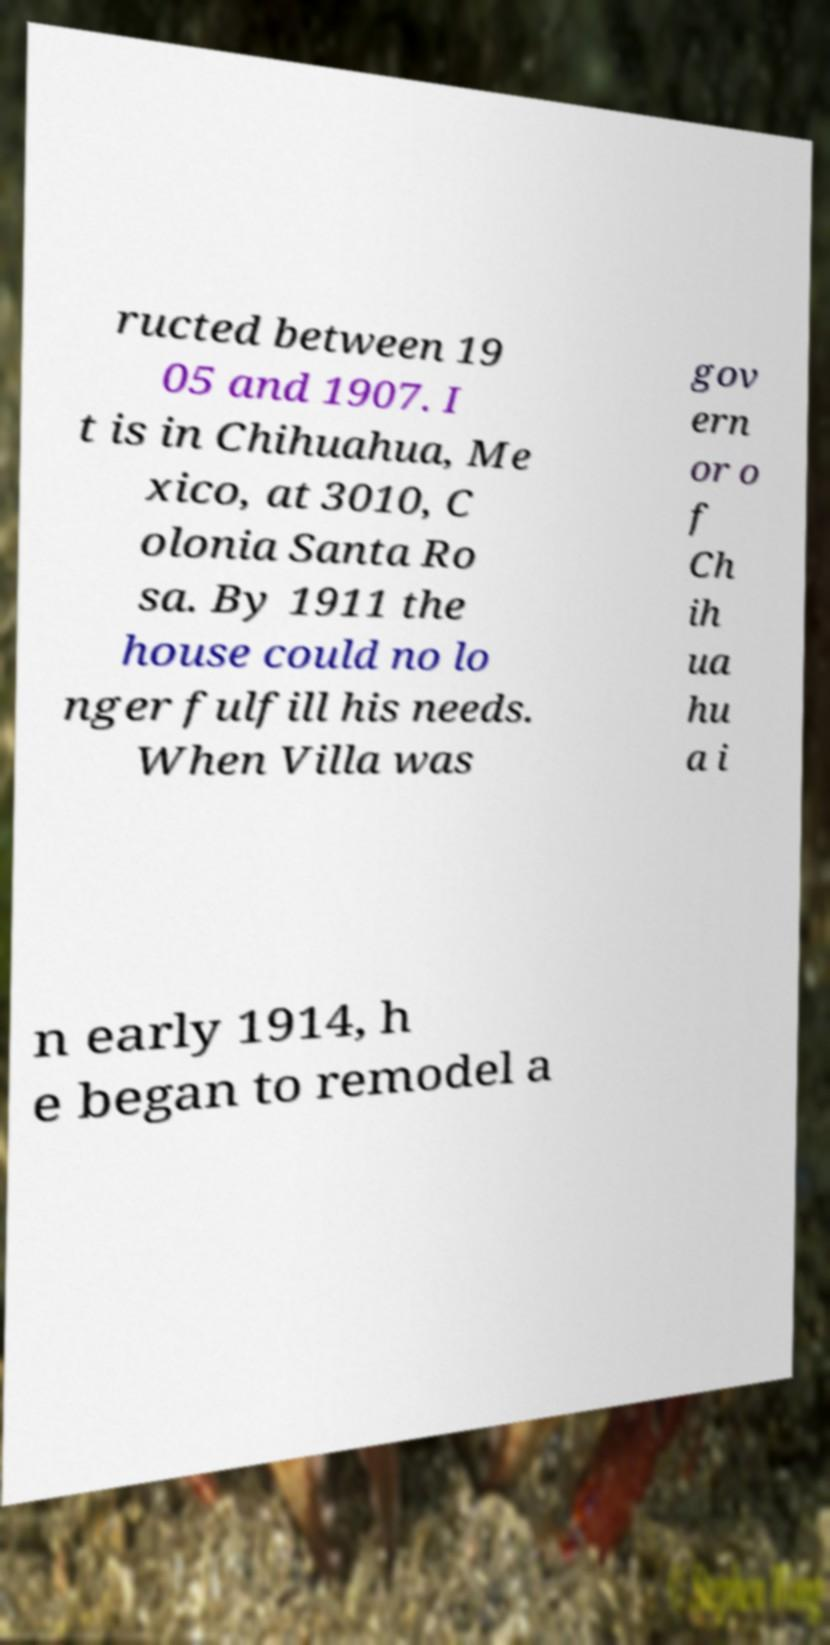For documentation purposes, I need the text within this image transcribed. Could you provide that? ructed between 19 05 and 1907. I t is in Chihuahua, Me xico, at 3010, C olonia Santa Ro sa. By 1911 the house could no lo nger fulfill his needs. When Villa was gov ern or o f Ch ih ua hu a i n early 1914, h e began to remodel a 